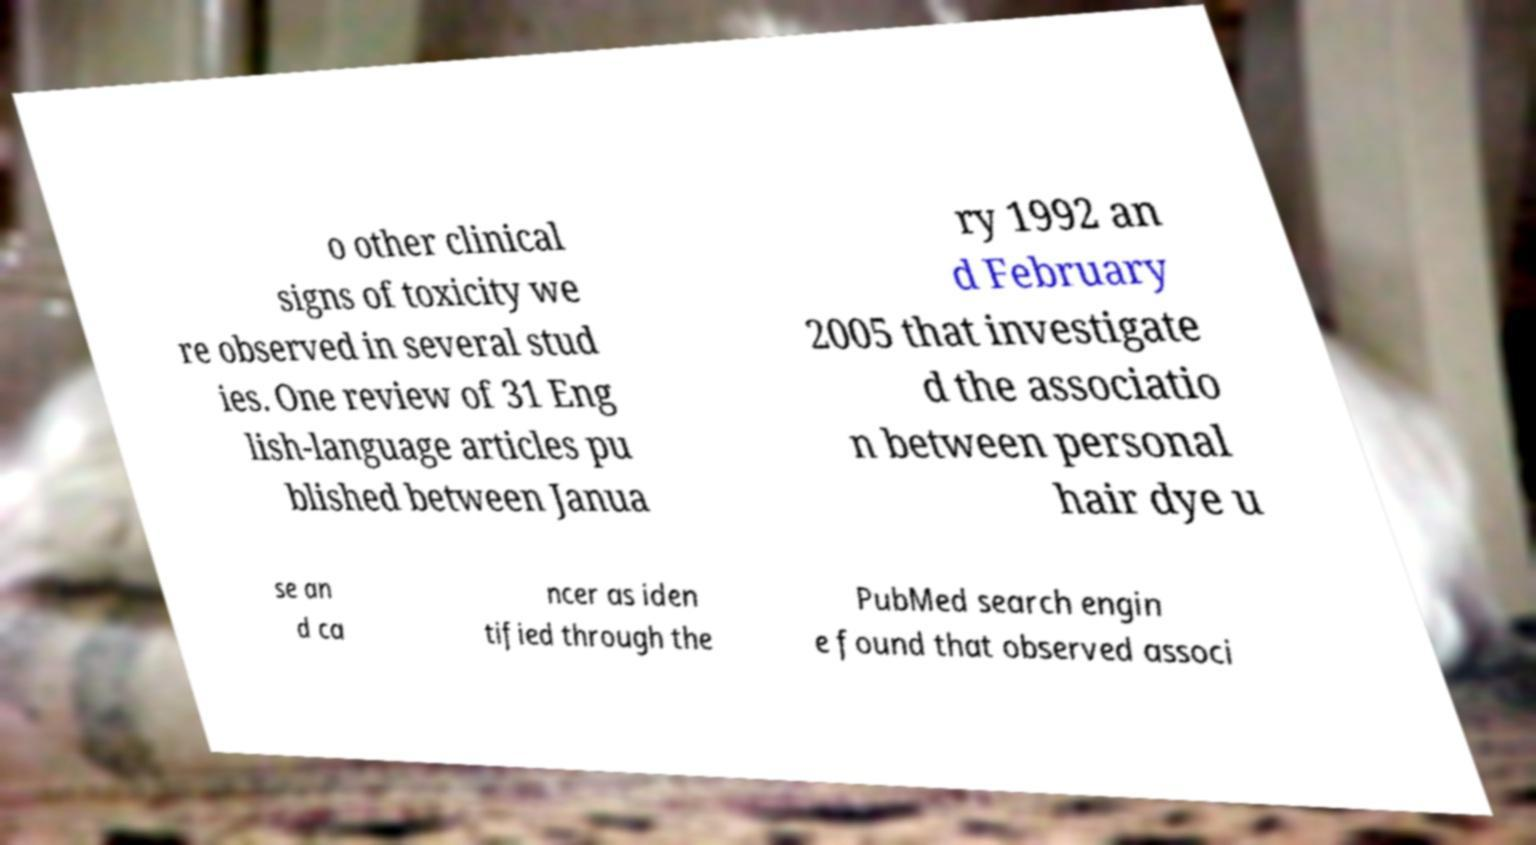Could you assist in decoding the text presented in this image and type it out clearly? o other clinical signs of toxicity we re observed in several stud ies. One review of 31 Eng lish-language articles pu blished between Janua ry 1992 an d February 2005 that investigate d the associatio n between personal hair dye u se an d ca ncer as iden tified through the PubMed search engin e found that observed associ 